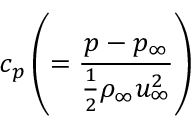<formula> <loc_0><loc_0><loc_500><loc_500>c _ { p } \left ( = \frac { p - p _ { \infty } } { \frac { 1 } { 2 } \rho _ { \infty } u _ { \infty } ^ { 2 } } \right )</formula> 